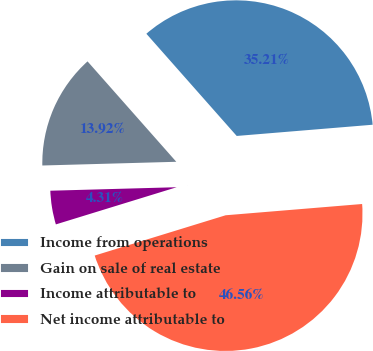Convert chart to OTSL. <chart><loc_0><loc_0><loc_500><loc_500><pie_chart><fcel>Income from operations<fcel>Gain on sale of real estate<fcel>Income attributable to<fcel>Net income attributable to<nl><fcel>35.21%<fcel>13.92%<fcel>4.31%<fcel>46.56%<nl></chart> 